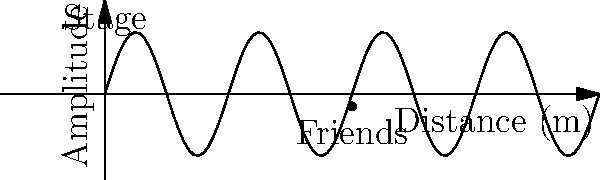At a reunion concert, you and your old classmates are standing 20 meters from the stage. If the sound wave from the speakers has a frequency of 440 Hz and travels at 343 m/s, what is the wavelength of the sound reaching you? To find the wavelength of the sound, we can use the wave equation:

$$ v = f \lambda $$

Where:
- $v$ is the speed of sound (343 m/s)
- $f$ is the frequency (440 Hz)
- $\lambda$ is the wavelength (what we're solving for)

Let's solve for $\lambda$:

1) Rearrange the equation:
   $$ \lambda = \frac{v}{f} $$

2) Substitute the known values:
   $$ \lambda = \frac{343 \text{ m/s}}{440 \text{ Hz}} $$

3) Calculate:
   $$ \lambda = 0.78 \text{ m} $$

Therefore, the wavelength of the sound reaching you and your friends is 0.78 meters.
Answer: 0.78 m 